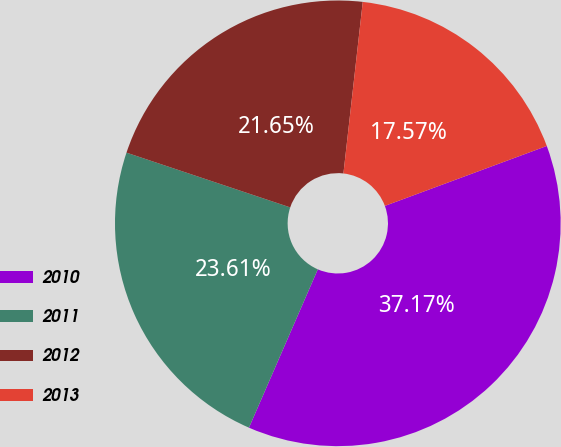<chart> <loc_0><loc_0><loc_500><loc_500><pie_chart><fcel>2010<fcel>2011<fcel>2012<fcel>2013<nl><fcel>37.17%<fcel>23.61%<fcel>21.65%<fcel>17.57%<nl></chart> 